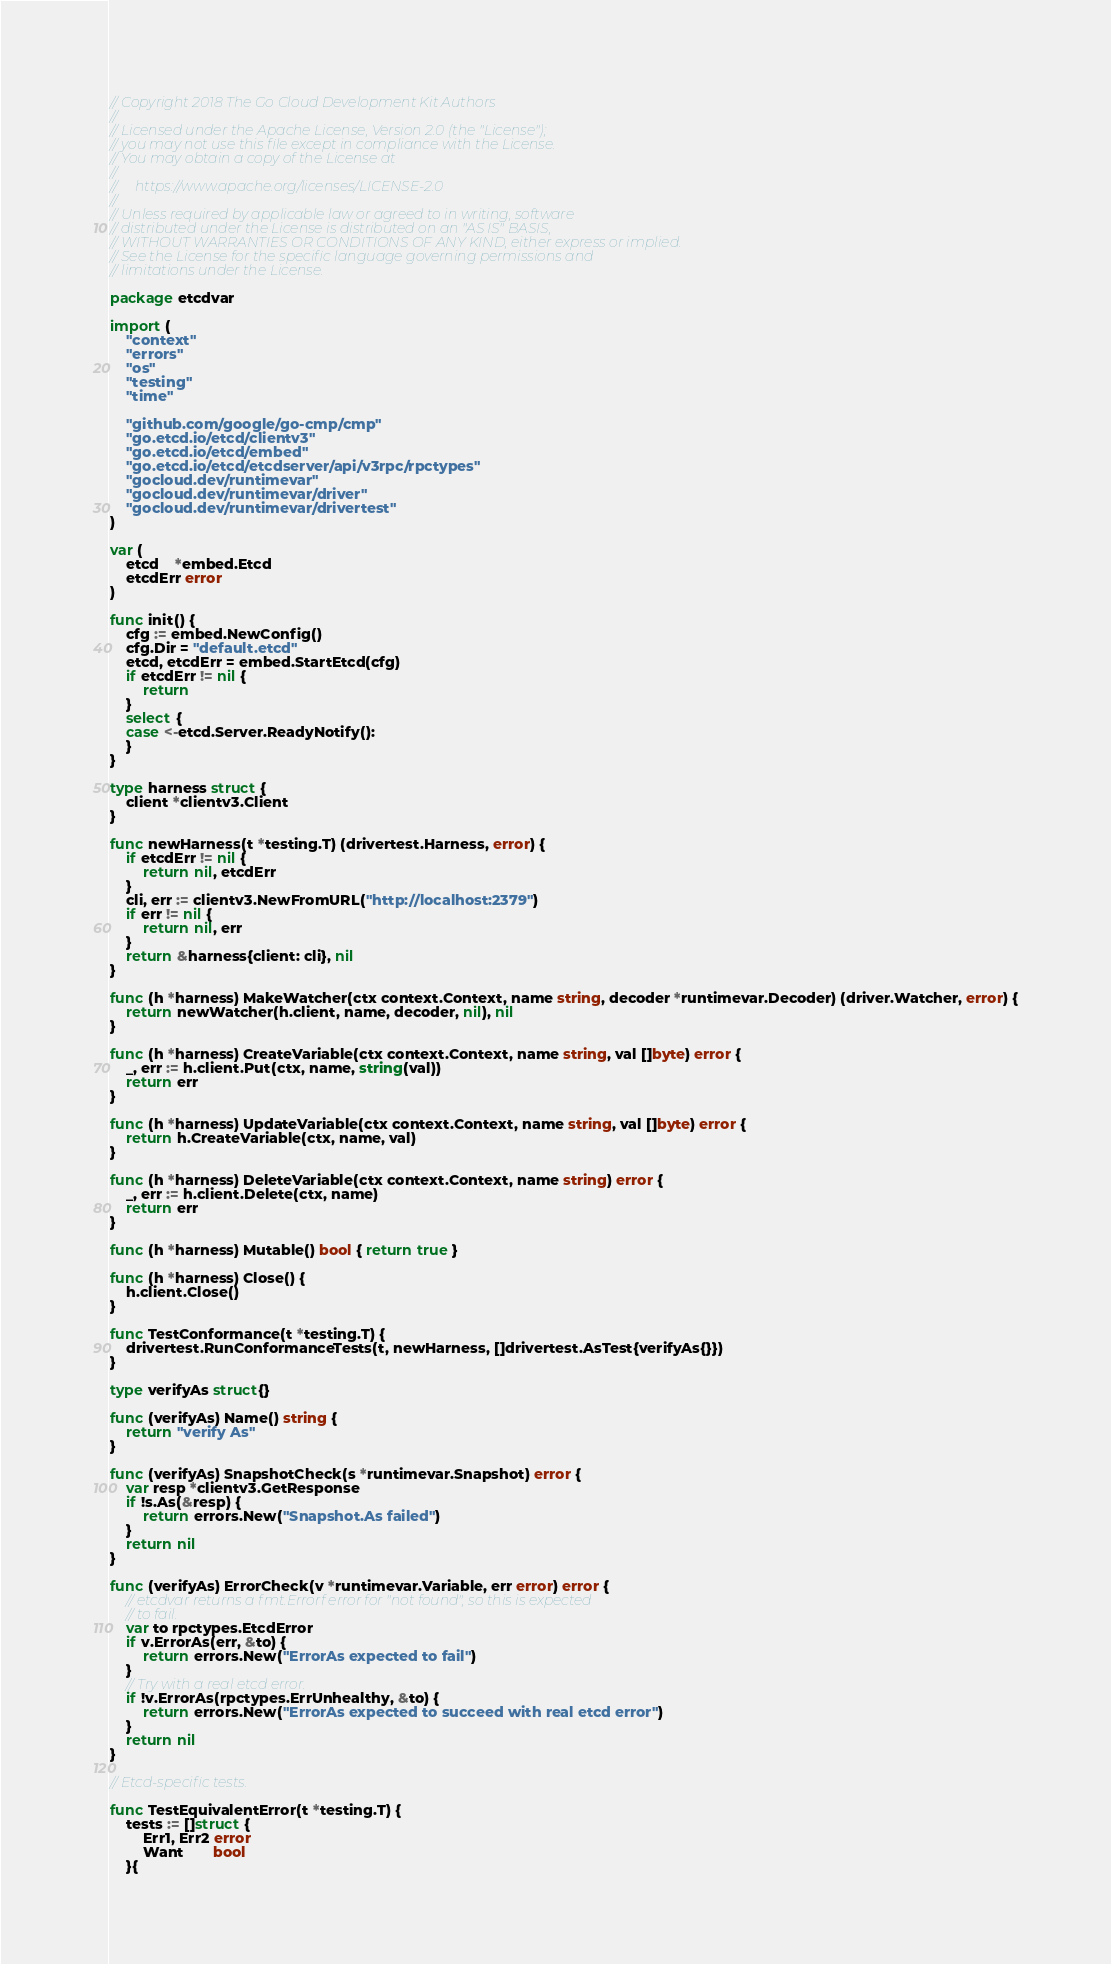<code> <loc_0><loc_0><loc_500><loc_500><_Go_>// Copyright 2018 The Go Cloud Development Kit Authors
//
// Licensed under the Apache License, Version 2.0 (the "License");
// you may not use this file except in compliance with the License.
// You may obtain a copy of the License at
//
//     https://www.apache.org/licenses/LICENSE-2.0
//
// Unless required by applicable law or agreed to in writing, software
// distributed under the License is distributed on an "AS IS" BASIS,
// WITHOUT WARRANTIES OR CONDITIONS OF ANY KIND, either express or implied.
// See the License for the specific language governing permissions and
// limitations under the License.

package etcdvar

import (
	"context"
	"errors"
	"os"
	"testing"
	"time"

	"github.com/google/go-cmp/cmp"
	"go.etcd.io/etcd/clientv3"
	"go.etcd.io/etcd/embed"
	"go.etcd.io/etcd/etcdserver/api/v3rpc/rpctypes"
	"gocloud.dev/runtimevar"
	"gocloud.dev/runtimevar/driver"
	"gocloud.dev/runtimevar/drivertest"
)

var (
	etcd    *embed.Etcd
	etcdErr error
)

func init() {
	cfg := embed.NewConfig()
	cfg.Dir = "default.etcd"
	etcd, etcdErr = embed.StartEtcd(cfg)
	if etcdErr != nil {
		return
	}
	select {
	case <-etcd.Server.ReadyNotify():
	}
}

type harness struct {
	client *clientv3.Client
}

func newHarness(t *testing.T) (drivertest.Harness, error) {
	if etcdErr != nil {
		return nil, etcdErr
	}
	cli, err := clientv3.NewFromURL("http://localhost:2379")
	if err != nil {
		return nil, err
	}
	return &harness{client: cli}, nil
}

func (h *harness) MakeWatcher(ctx context.Context, name string, decoder *runtimevar.Decoder) (driver.Watcher, error) {
	return newWatcher(h.client, name, decoder, nil), nil
}

func (h *harness) CreateVariable(ctx context.Context, name string, val []byte) error {
	_, err := h.client.Put(ctx, name, string(val))
	return err
}

func (h *harness) UpdateVariable(ctx context.Context, name string, val []byte) error {
	return h.CreateVariable(ctx, name, val)
}

func (h *harness) DeleteVariable(ctx context.Context, name string) error {
	_, err := h.client.Delete(ctx, name)
	return err
}

func (h *harness) Mutable() bool { return true }

func (h *harness) Close() {
	h.client.Close()
}

func TestConformance(t *testing.T) {
	drivertest.RunConformanceTests(t, newHarness, []drivertest.AsTest{verifyAs{}})
}

type verifyAs struct{}

func (verifyAs) Name() string {
	return "verify As"
}

func (verifyAs) SnapshotCheck(s *runtimevar.Snapshot) error {
	var resp *clientv3.GetResponse
	if !s.As(&resp) {
		return errors.New("Snapshot.As failed")
	}
	return nil
}

func (verifyAs) ErrorCheck(v *runtimevar.Variable, err error) error {
	// etcdvar returns a fmt.Errorf error for "not found", so this is expected
	// to fail.
	var to rpctypes.EtcdError
	if v.ErrorAs(err, &to) {
		return errors.New("ErrorAs expected to fail")
	}
	// Try with a real etcd error.
	if !v.ErrorAs(rpctypes.ErrUnhealthy, &to) {
		return errors.New("ErrorAs expected to succeed with real etcd error")
	}
	return nil
}

// Etcd-specific tests.

func TestEquivalentError(t *testing.T) {
	tests := []struct {
		Err1, Err2 error
		Want       bool
	}{</code> 